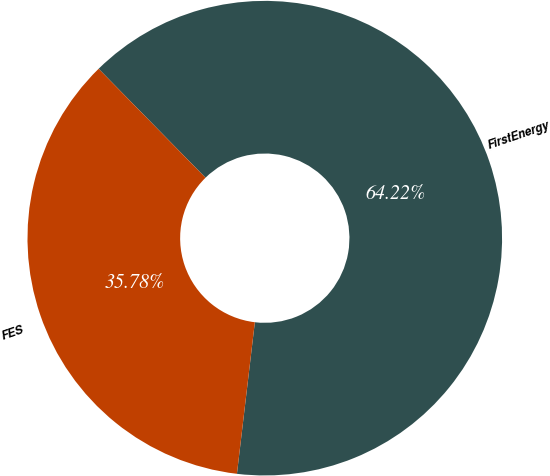Convert chart to OTSL. <chart><loc_0><loc_0><loc_500><loc_500><pie_chart><fcel>FirstEnergy<fcel>FES<nl><fcel>64.22%<fcel>35.78%<nl></chart> 